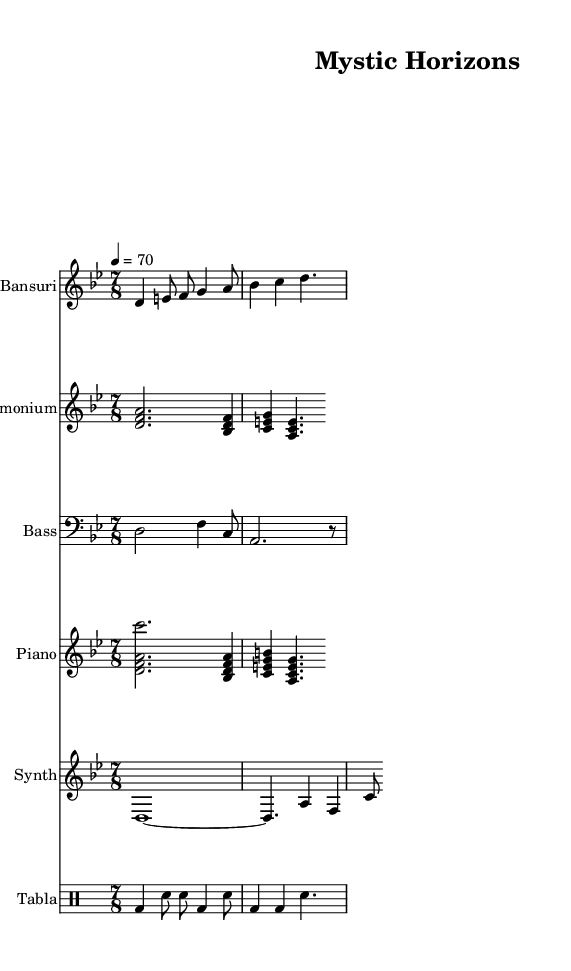What is the key signature of this music? The key signature is D Phrygian, indicated by the key signature symbol at the beginning of the score. The presence of the note D and the phrygian mode further confirm this key.
Answer: D Phrygian What is the time signature of the piece? The time signature of the music is 7/8, which is indicated at the beginning of the score. This means there are seven beats in each measure, with an eighth note receiving one beat.
Answer: 7/8 What is the tempo marking for this composition? The tempo marking is 4 = 70, which specifies that the quarter note should be played at a speed of 70 beats per minute. This is located near the top of the score in the global settings.
Answer: 70 Which instruments are featured in this sheet music? The instruments featured in this sheet music are Bansuri, Harmonium, Bass, Piano, Synth, and Tabla. Each set of music is labeled with the corresponding instrument name at the beginning of each staff.
Answer: Bansuri, Harmonium, Bass, Piano, Synth, Tabla How many measures are indicated for the Bansuri part? The Bansuri part has a total of three measures indicated in the provided excerpt. Counting the vertical bar lines, which separate each measure, allows us to determine this total.
Answer: 3 What rhythmic pattern does the Tabla play in the first measure? The Tabla plays a pattern consisting of one bass drum hit followed by two snare hits and another bass hit. This rhythmic structure is notated in the drum staff specifically for the Tabla instrument.
Answer: bd, sn, sn, bd 